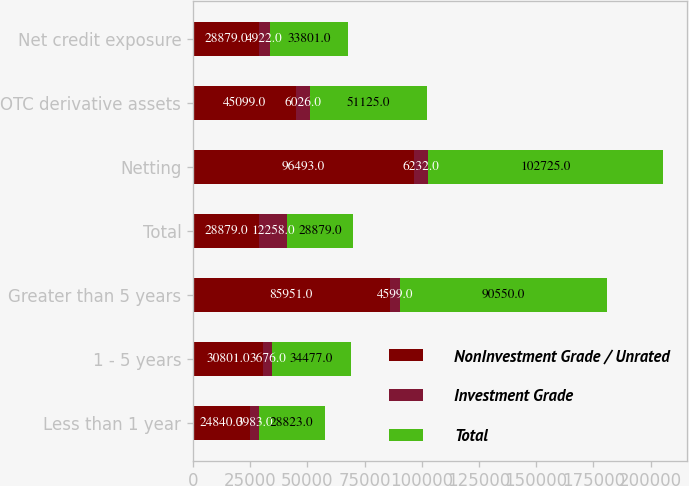Convert chart to OTSL. <chart><loc_0><loc_0><loc_500><loc_500><stacked_bar_chart><ecel><fcel>Less than 1 year<fcel>1 - 5 years<fcel>Greater than 5 years<fcel>Total<fcel>Netting<fcel>OTC derivative assets<fcel>Net credit exposure<nl><fcel>NonInvestment Grade / Unrated<fcel>24840<fcel>30801<fcel>85951<fcel>28879<fcel>96493<fcel>45099<fcel>28879<nl><fcel>Investment Grade<fcel>3983<fcel>3676<fcel>4599<fcel>12258<fcel>6232<fcel>6026<fcel>4922<nl><fcel>Total<fcel>28823<fcel>34477<fcel>90550<fcel>28879<fcel>102725<fcel>51125<fcel>33801<nl></chart> 